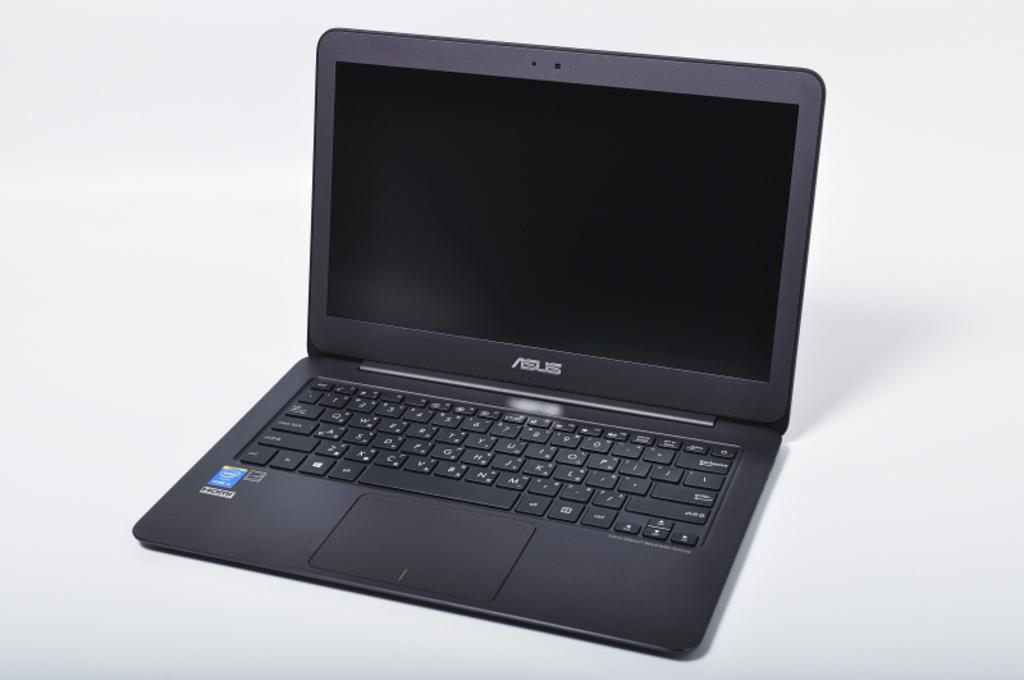<image>
Render a clear and concise summary of the photo. An ASUS brand laptop against a white background. 